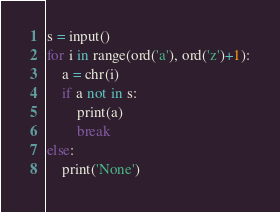<code> <loc_0><loc_0><loc_500><loc_500><_Python_>s = input()
for i in range(ord('a'), ord('z')+1):
    a = chr(i)
    if a not in s:
        print(a)
        break
else:
    print('None')</code> 